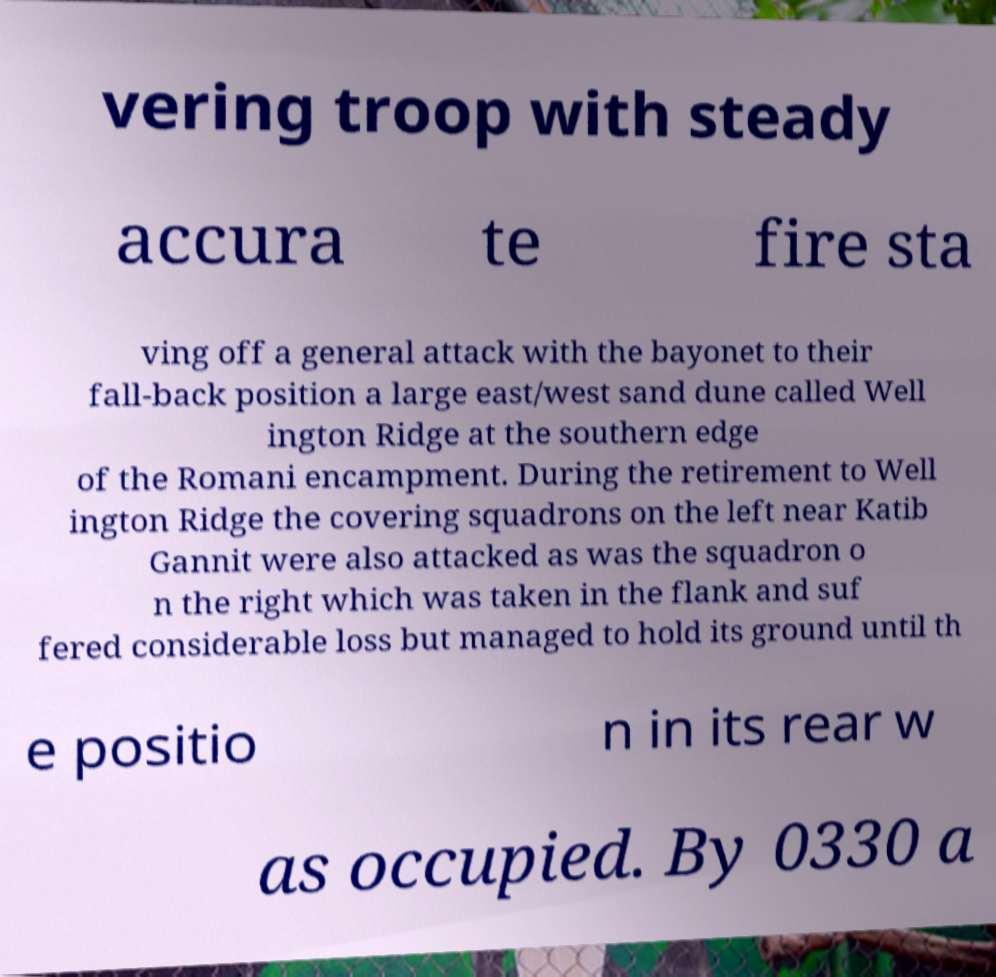Please identify and transcribe the text found in this image. vering troop with steady accura te fire sta ving off a general attack with the bayonet to their fall-back position a large east/west sand dune called Well ington Ridge at the southern edge of the Romani encampment. During the retirement to Well ington Ridge the covering squadrons on the left near Katib Gannit were also attacked as was the squadron o n the right which was taken in the flank and suf fered considerable loss but managed to hold its ground until th e positio n in its rear w as occupied. By 0330 a 